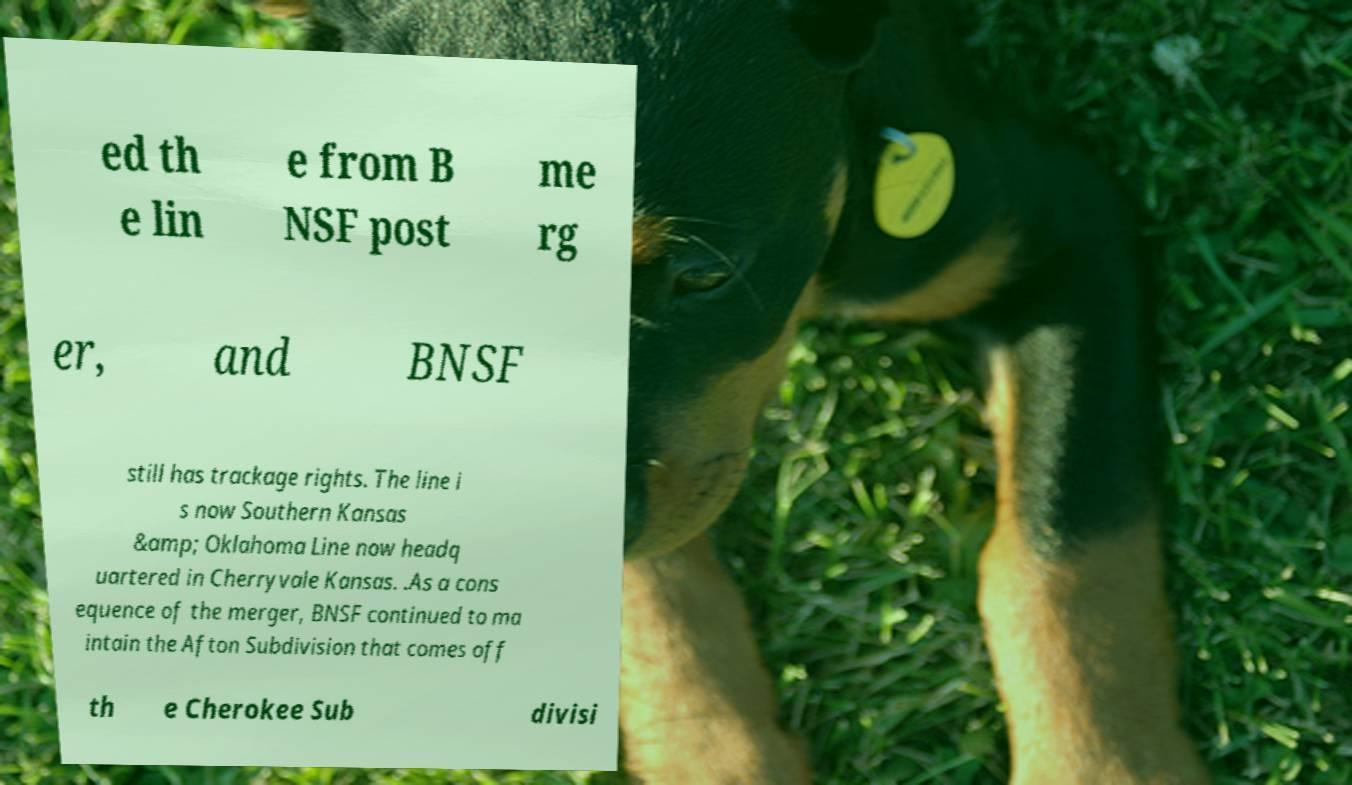Can you read and provide the text displayed in the image?This photo seems to have some interesting text. Can you extract and type it out for me? ed th e lin e from B NSF post me rg er, and BNSF still has trackage rights. The line i s now Southern Kansas &amp; Oklahoma Line now headq uartered in Cherryvale Kansas. .As a cons equence of the merger, BNSF continued to ma intain the Afton Subdivision that comes off th e Cherokee Sub divisi 